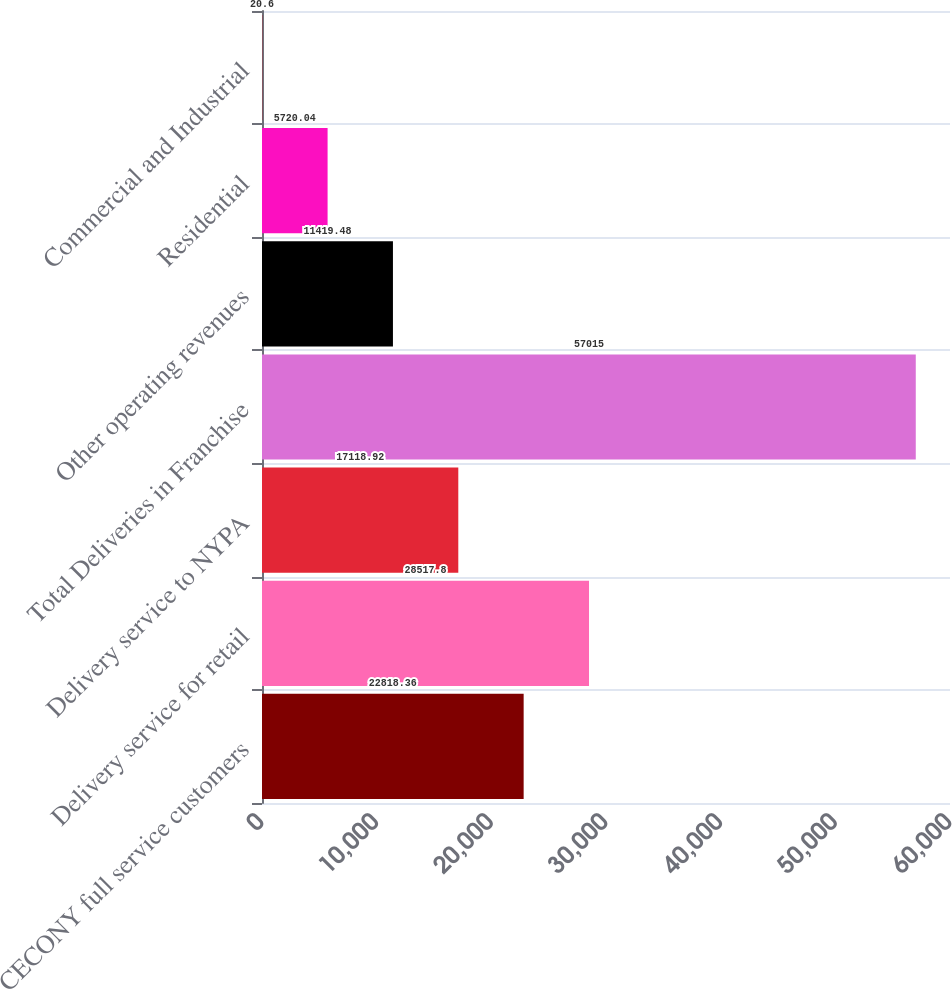<chart> <loc_0><loc_0><loc_500><loc_500><bar_chart><fcel>CECONY full service customers<fcel>Delivery service for retail<fcel>Delivery service to NYPA<fcel>Total Deliveries in Franchise<fcel>Other operating revenues<fcel>Residential<fcel>Commercial and Industrial<nl><fcel>22818.4<fcel>28517.8<fcel>17118.9<fcel>57015<fcel>11419.5<fcel>5720.04<fcel>20.6<nl></chart> 